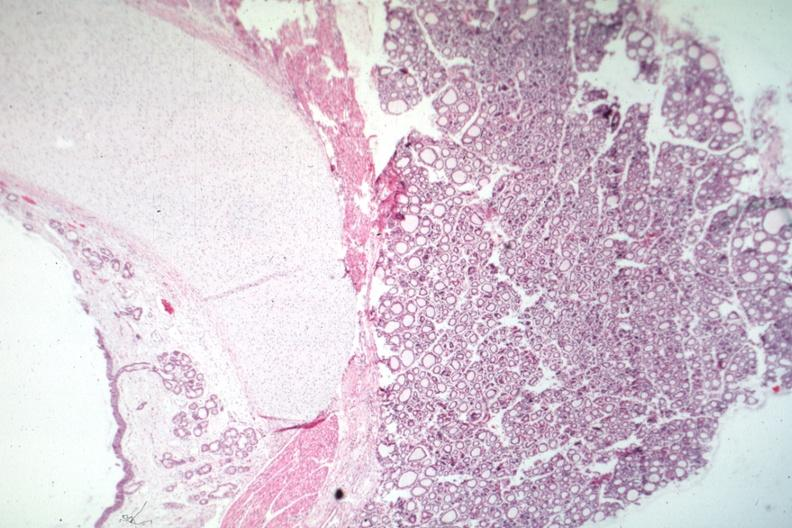s peritoneal fluid present?
Answer the question using a single word or phrase. No 